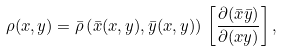Convert formula to latex. <formula><loc_0><loc_0><loc_500><loc_500>\rho ( x , y ) = \bar { \rho } \left ( \bar { x } ( x , y ) , \bar { y } ( x , y ) \right ) \, \left [ \frac { \partial ( \bar { x } \bar { y } ) } { \partial ( x y ) } \right ] ,</formula> 